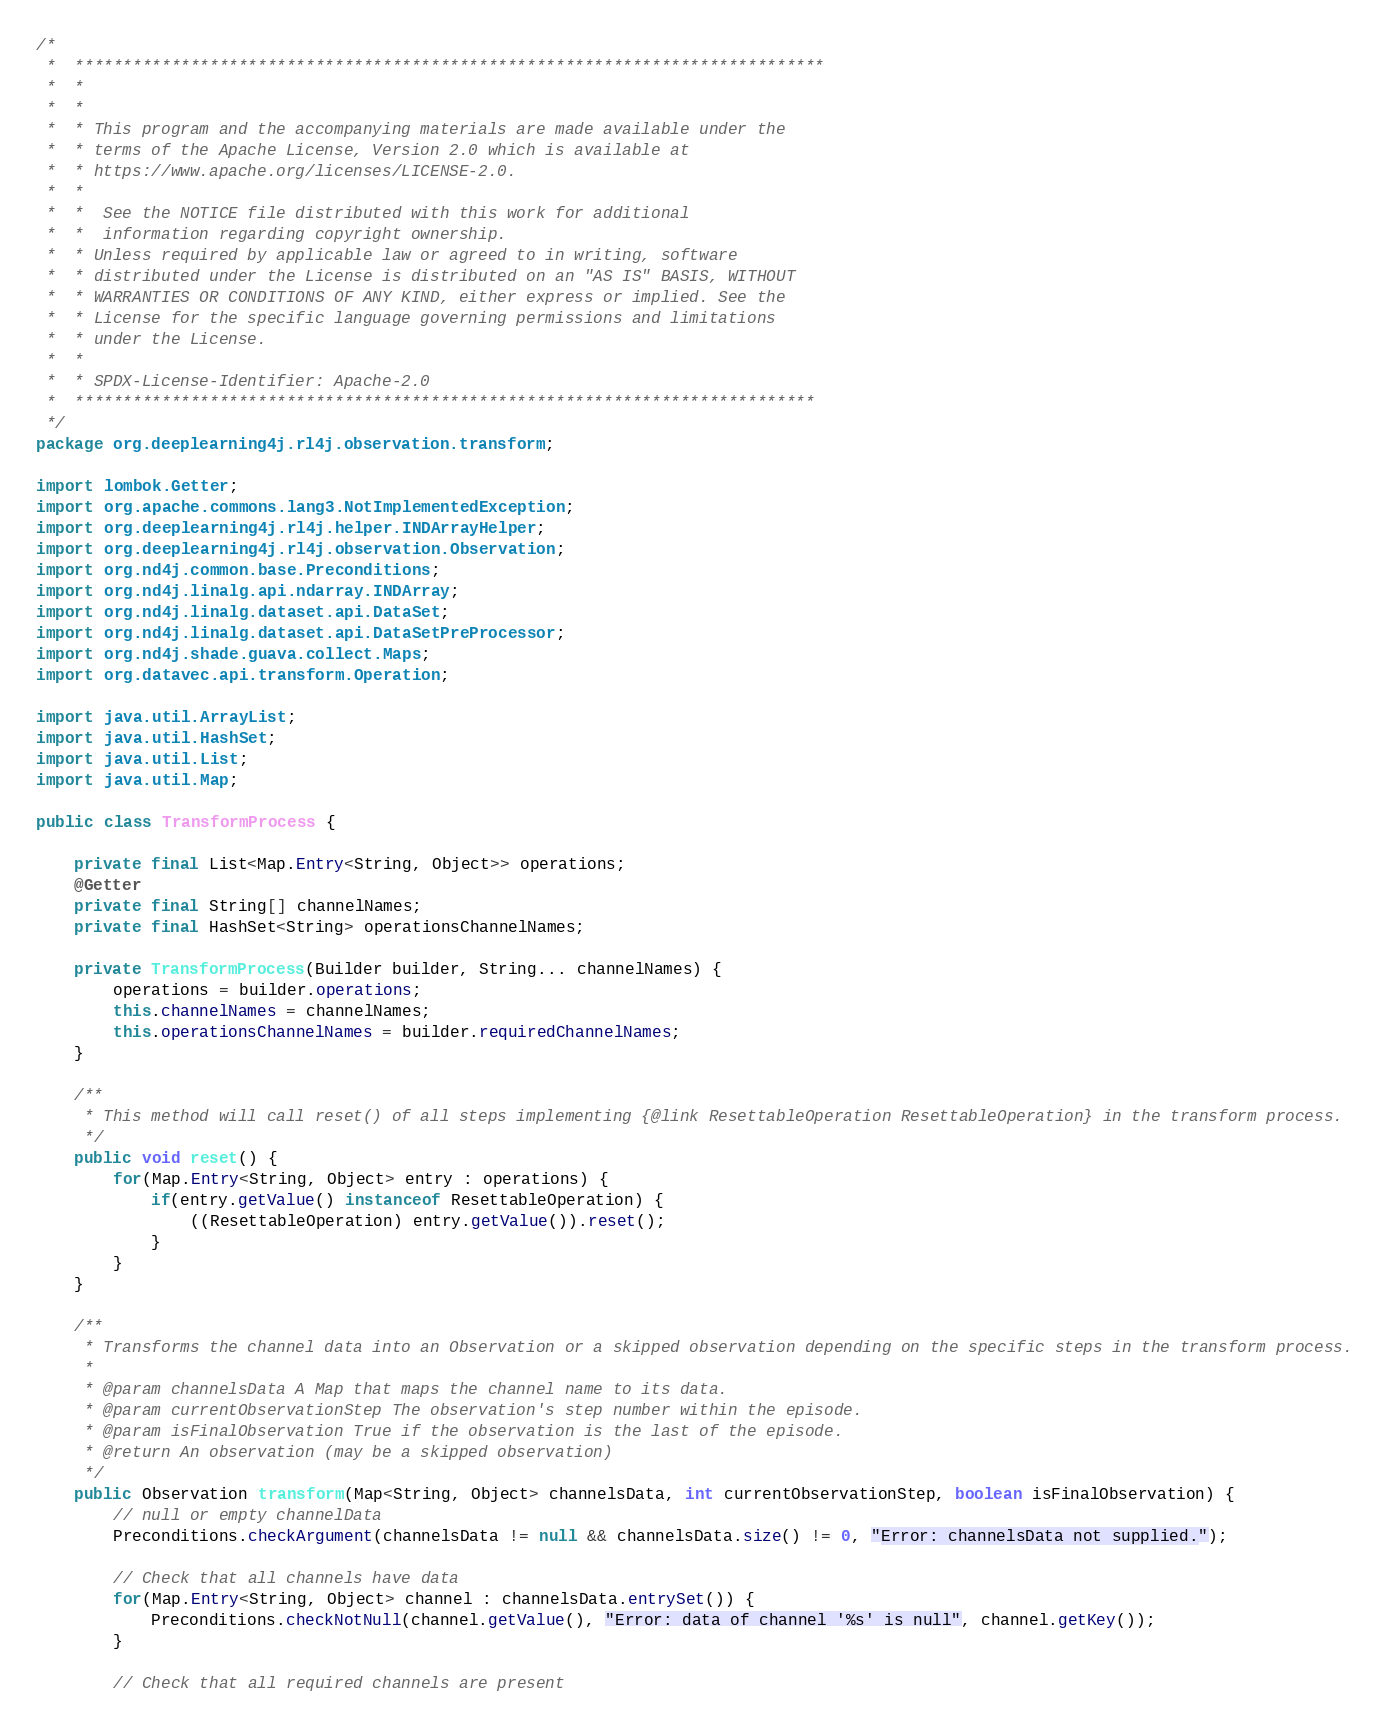<code> <loc_0><loc_0><loc_500><loc_500><_Java_>/*
 *  ******************************************************************************
 *  *
 *  *
 *  * This program and the accompanying materials are made available under the
 *  * terms of the Apache License, Version 2.0 which is available at
 *  * https://www.apache.org/licenses/LICENSE-2.0.
 *  *
 *  *  See the NOTICE file distributed with this work for additional
 *  *  information regarding copyright ownership.
 *  * Unless required by applicable law or agreed to in writing, software
 *  * distributed under the License is distributed on an "AS IS" BASIS, WITHOUT
 *  * WARRANTIES OR CONDITIONS OF ANY KIND, either express or implied. See the
 *  * License for the specific language governing permissions and limitations
 *  * under the License.
 *  *
 *  * SPDX-License-Identifier: Apache-2.0
 *  *****************************************************************************
 */
package org.deeplearning4j.rl4j.observation.transform;

import lombok.Getter;
import org.apache.commons.lang3.NotImplementedException;
import org.deeplearning4j.rl4j.helper.INDArrayHelper;
import org.deeplearning4j.rl4j.observation.Observation;
import org.nd4j.common.base.Preconditions;
import org.nd4j.linalg.api.ndarray.INDArray;
import org.nd4j.linalg.dataset.api.DataSet;
import org.nd4j.linalg.dataset.api.DataSetPreProcessor;
import org.nd4j.shade.guava.collect.Maps;
import org.datavec.api.transform.Operation;

import java.util.ArrayList;
import java.util.HashSet;
import java.util.List;
import java.util.Map;

public class TransformProcess {

    private final List<Map.Entry<String, Object>> operations;
    @Getter
    private final String[] channelNames;
    private final HashSet<String> operationsChannelNames;

    private TransformProcess(Builder builder, String... channelNames) {
        operations = builder.operations;
        this.channelNames = channelNames;
        this.operationsChannelNames = builder.requiredChannelNames;
    }

    /**
     * This method will call reset() of all steps implementing {@link ResettableOperation ResettableOperation} in the transform process.
     */
    public void reset() {
        for(Map.Entry<String, Object> entry : operations) {
            if(entry.getValue() instanceof ResettableOperation) {
                ((ResettableOperation) entry.getValue()).reset();
            }
        }
    }

    /**
     * Transforms the channel data into an Observation or a skipped observation depending on the specific steps in the transform process.
     *
     * @param channelsData A Map that maps the channel name to its data.
     * @param currentObservationStep The observation's step number within the episode.
     * @param isFinalObservation True if the observation is the last of the episode.
     * @return An observation (may be a skipped observation)
     */
    public Observation transform(Map<String, Object> channelsData, int currentObservationStep, boolean isFinalObservation) {
        // null or empty channelData
        Preconditions.checkArgument(channelsData != null && channelsData.size() != 0, "Error: channelsData not supplied.");

        // Check that all channels have data
        for(Map.Entry<String, Object> channel : channelsData.entrySet()) {
            Preconditions.checkNotNull(channel.getValue(), "Error: data of channel '%s' is null", channel.getKey());
        }

        // Check that all required channels are present</code> 